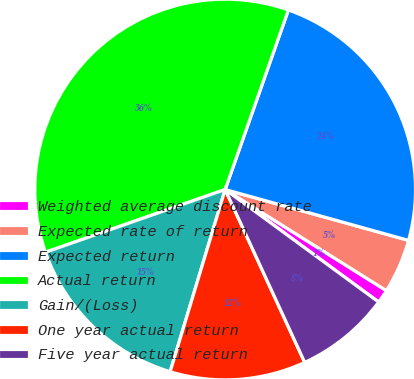<chart> <loc_0><loc_0><loc_500><loc_500><pie_chart><fcel>Weighted average discount rate<fcel>Expected rate of return<fcel>Expected return<fcel>Actual return<fcel>Gain/(Loss)<fcel>One year actual return<fcel>Five year actual return<nl><fcel>1.15%<fcel>4.61%<fcel>23.92%<fcel>35.74%<fcel>14.99%<fcel>11.53%<fcel>8.07%<nl></chart> 